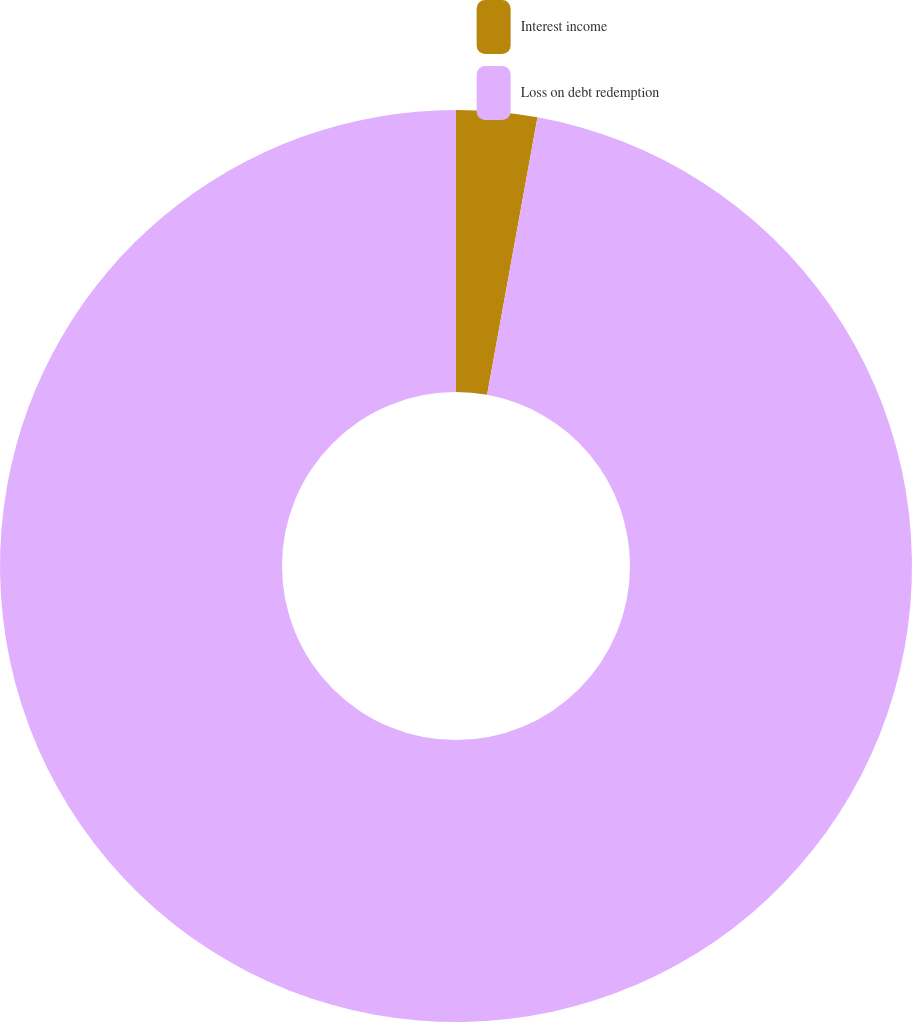Convert chart to OTSL. <chart><loc_0><loc_0><loc_500><loc_500><pie_chart><fcel>Interest income<fcel>Loss on debt redemption<nl><fcel>2.86%<fcel>97.14%<nl></chart> 